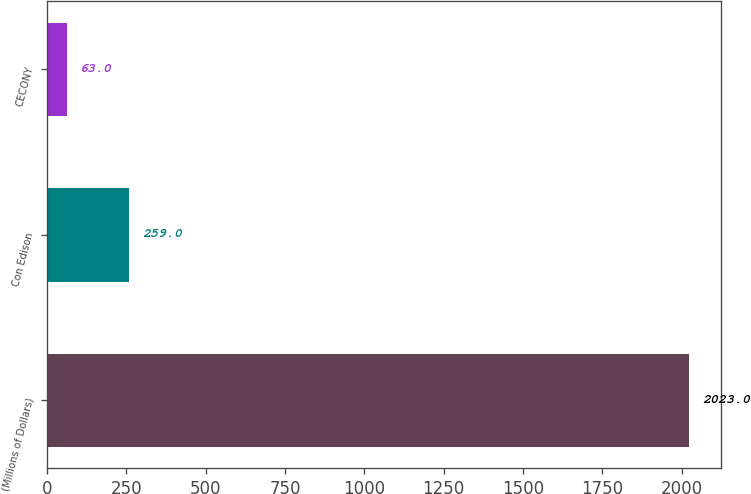Convert chart to OTSL. <chart><loc_0><loc_0><loc_500><loc_500><bar_chart><fcel>(Millions of Dollars)<fcel>Con Edison<fcel>CECONY<nl><fcel>2023<fcel>259<fcel>63<nl></chart> 